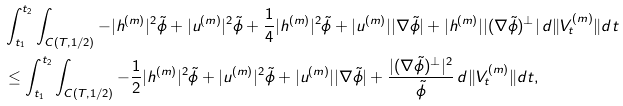Convert formula to latex. <formula><loc_0><loc_0><loc_500><loc_500>& \int _ { t _ { 1 } } ^ { t _ { 2 } } \int _ { C ( T , 1 / 2 ) } - | h ^ { ( m ) } | ^ { 2 } \tilde { \phi } + | u ^ { ( m ) } | ^ { 2 } \tilde { \phi } + \frac { 1 } { 4 } | h ^ { ( m ) } | ^ { 2 } \tilde { \phi } + | u ^ { ( m ) } | | \nabla \tilde { \phi } | + | h ^ { ( m ) } | | ( \nabla \tilde { \phi } ) ^ { \perp } | \, d \| V _ { t } ^ { ( m ) } \| d t \\ & \leq \int _ { t _ { 1 } } ^ { t _ { 2 } } \int _ { C ( T , 1 / 2 ) } - \frac { 1 } { 2 } | h ^ { ( m ) } | ^ { 2 } \tilde { \phi } + | u ^ { ( m ) } | ^ { 2 } \tilde { \phi } + | u ^ { ( m ) } | | \nabla \tilde { \phi } | + \frac { | ( \nabla \tilde { \phi } ) ^ { \perp } | ^ { 2 } } { \tilde { \phi } } \, d \| V _ { t } ^ { ( m ) } \| d t ,</formula> 